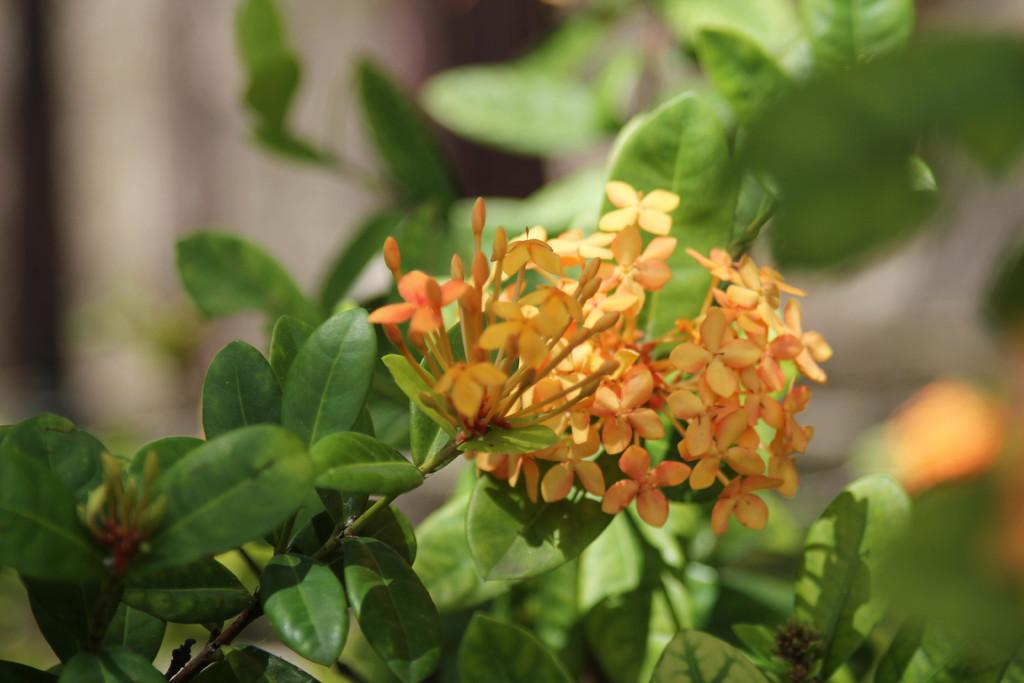What type of photography is used in the image? The image is a macro photography. What is the main subject of the macro photography? The subject of the macro photography is a plant. What can be observed on the plant in the image? The plant has a bunch of flowers. What type of circle can be seen on the rod in the playground in the image? There is no circle, rod, or playground present in the image. The image features a macro photograph of a plant with a bunch of flowers. 